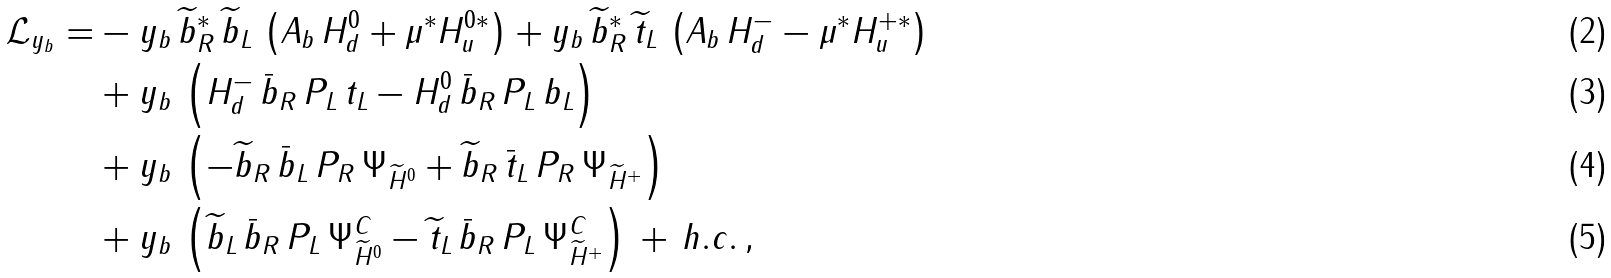Convert formula to latex. <formula><loc_0><loc_0><loc_500><loc_500>\mathcal { L } _ { y _ { b } } = & - y _ { b } \, \widetilde { b } _ { R } ^ { * } \, \widetilde { b } _ { L } \, \left ( A _ { b } \, H _ { d } ^ { 0 } + \mu ^ { * } H _ { u } ^ { 0 * } \right ) + y _ { b } \, \widetilde { b } _ { R } ^ { * } \, \widetilde { t } _ { L } \, \left ( A _ { b } \, H _ { d } ^ { - } - \mu ^ { * } H _ { u } ^ { + * } \right ) \\ & + y _ { b } \, \left ( H _ { d } ^ { - } \, \bar { b } _ { R } \, P _ { L } \, t _ { L } - H _ { d } ^ { 0 } \, \bar { b } _ { R } \, P _ { L } \, b _ { L } \right ) \\ & + y _ { b } \, \left ( - \widetilde { b } _ { R } \, \bar { b } _ { L } \, P _ { R } \, \Psi _ { \widetilde { H } ^ { 0 } } + \widetilde { b } _ { R } \, \bar { t } _ { L } \, P _ { R } \, \Psi _ { \widetilde { H } ^ { + } } \right ) \\ & + y _ { b } \, \left ( \widetilde { b } _ { L } \, \bar { b } _ { R } \, P _ { L } \, \Psi _ { \widetilde { H } ^ { 0 } } ^ { C } - \widetilde { t } _ { L } \, \bar { b } _ { R } \, P _ { L } \, \Psi _ { \widetilde { H } ^ { + } } ^ { C } \right ) \, + \, h . c . \, ,</formula> 